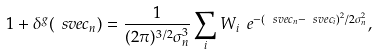<formula> <loc_0><loc_0><loc_500><loc_500>1 + \delta ^ { g } ( \ s v e c _ { n } ) = \frac { 1 } { ( 2 \pi ) ^ { 3 / 2 } \sigma _ { n } ^ { 3 } } \sum _ { i } W _ { i } \ e ^ { - ( \ s v e c _ { n } - \ s v e c _ { i } ) ^ { 2 } / 2 \sigma _ { n } ^ { 2 } } ,</formula> 